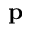<formula> <loc_0><loc_0><loc_500><loc_500>p</formula> 